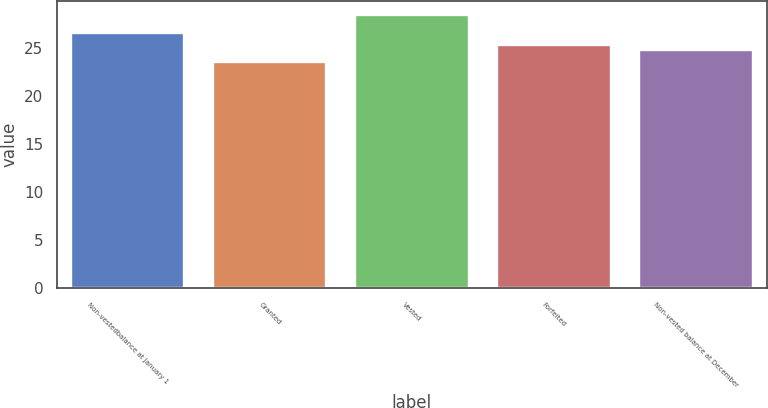Convert chart. <chart><loc_0><loc_0><loc_500><loc_500><bar_chart><fcel>Non-vestedbalance at January 1<fcel>Granted<fcel>Vested<fcel>Forfeited<fcel>Non-vested balance at December<nl><fcel>26.63<fcel>23.56<fcel>28.47<fcel>25.33<fcel>24.84<nl></chart> 